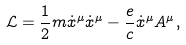<formula> <loc_0><loc_0><loc_500><loc_500>\mathcal { L } = \frac { 1 } { 2 } m \dot { x } ^ { \mu } \dot { x } ^ { \mu } - \frac { e } { c } \dot { x } ^ { \mu } A ^ { \mu } ,</formula> 